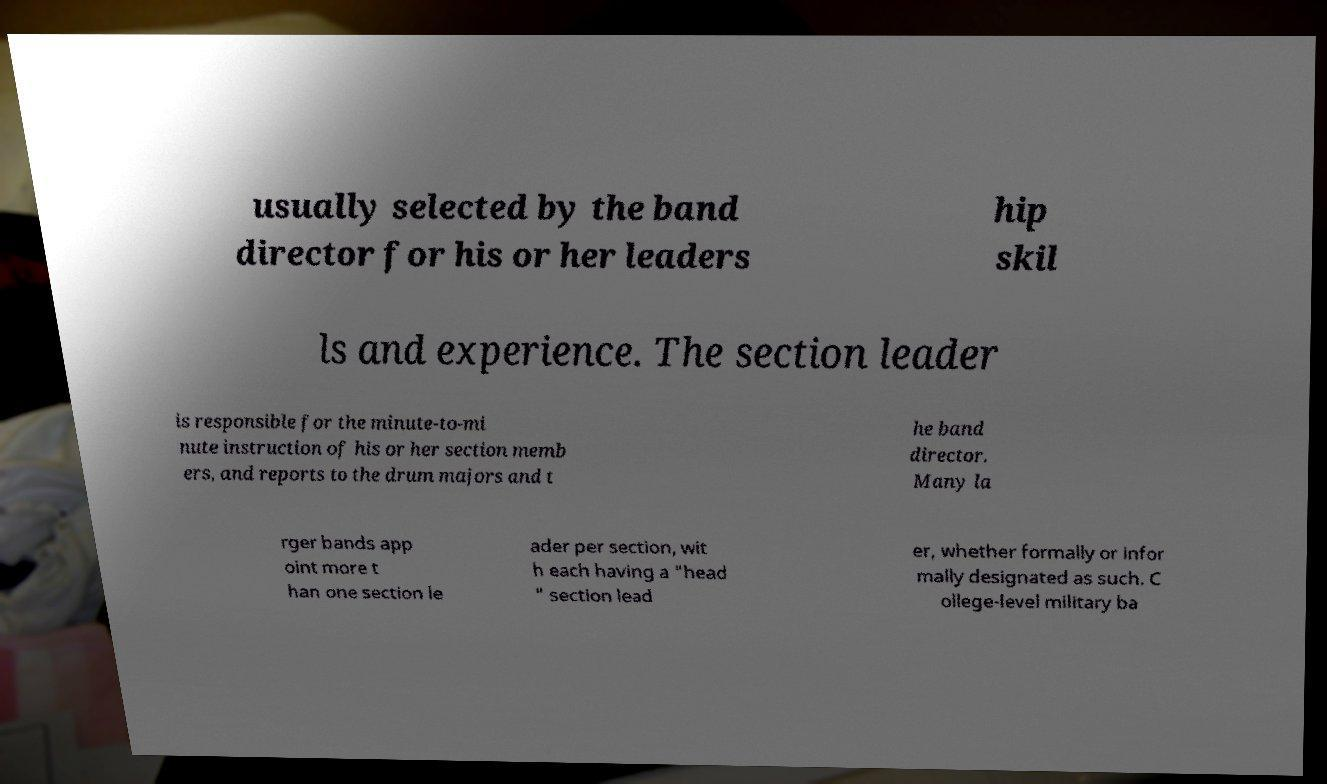For documentation purposes, I need the text within this image transcribed. Could you provide that? usually selected by the band director for his or her leaders hip skil ls and experience. The section leader is responsible for the minute-to-mi nute instruction of his or her section memb ers, and reports to the drum majors and t he band director. Many la rger bands app oint more t han one section le ader per section, wit h each having a "head " section lead er, whether formally or infor mally designated as such. C ollege-level military ba 